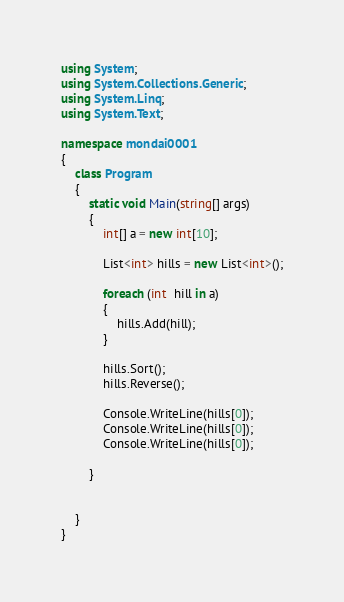<code> <loc_0><loc_0><loc_500><loc_500><_C#_>using System;
using System.Collections.Generic;
using System.Linq;
using System.Text;

namespace mondai0001
{
    class Program
    {
        static void Main(string[] args)
        {
            int[] a = new int[10];

            List<int> hills = new List<int>();

            foreach (int  hill in a)
            {
                hills.Add(hill);
            }

            hills.Sort();
            hills.Reverse();

            Console.WriteLine(hills[0]);
            Console.WriteLine(hills[0]);
            Console.WriteLine(hills[0]);

        }

        
    }
}</code> 